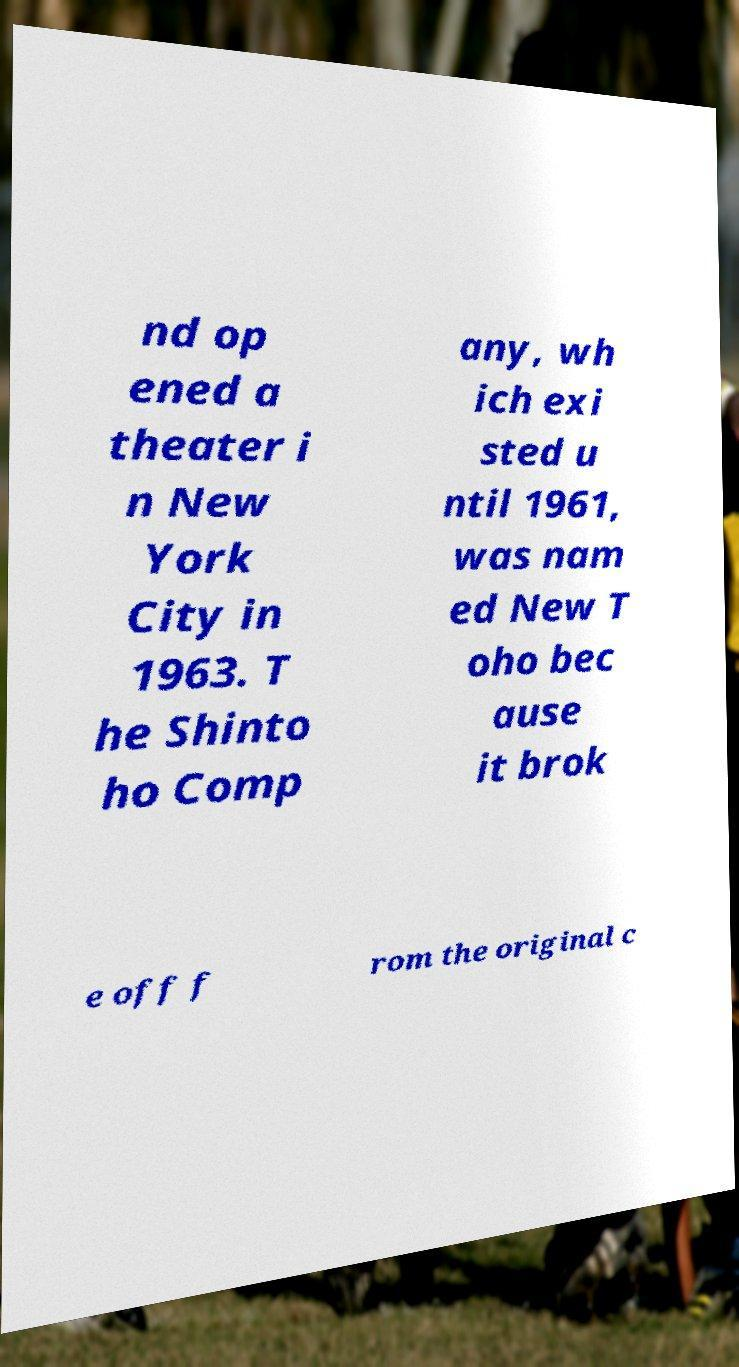There's text embedded in this image that I need extracted. Can you transcribe it verbatim? nd op ened a theater i n New York City in 1963. T he Shinto ho Comp any, wh ich exi sted u ntil 1961, was nam ed New T oho bec ause it brok e off f rom the original c 